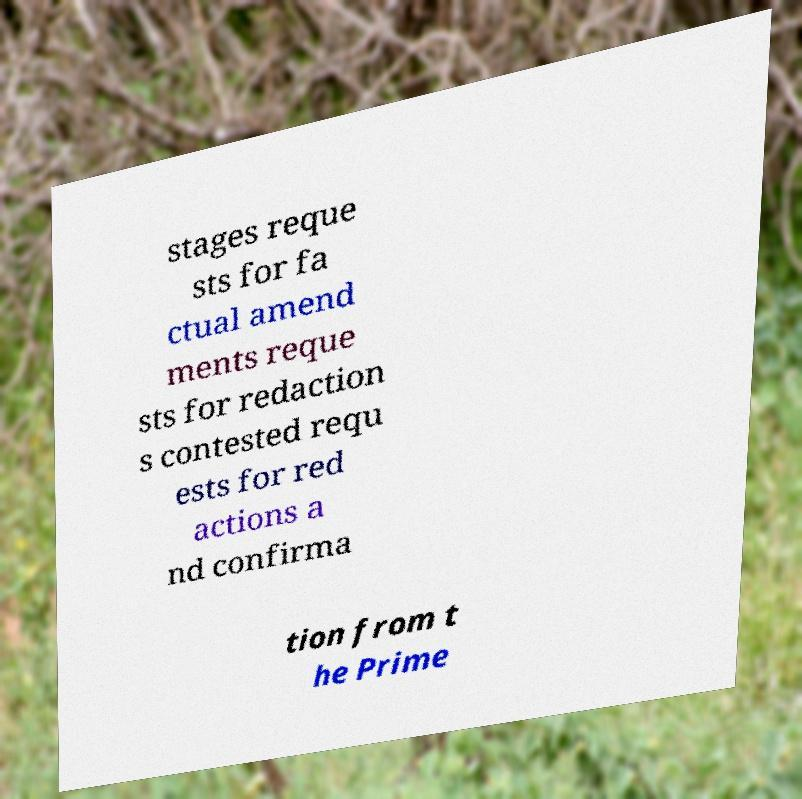Could you assist in decoding the text presented in this image and type it out clearly? stages reque sts for fa ctual amend ments reque sts for redaction s contested requ ests for red actions a nd confirma tion from t he Prime 